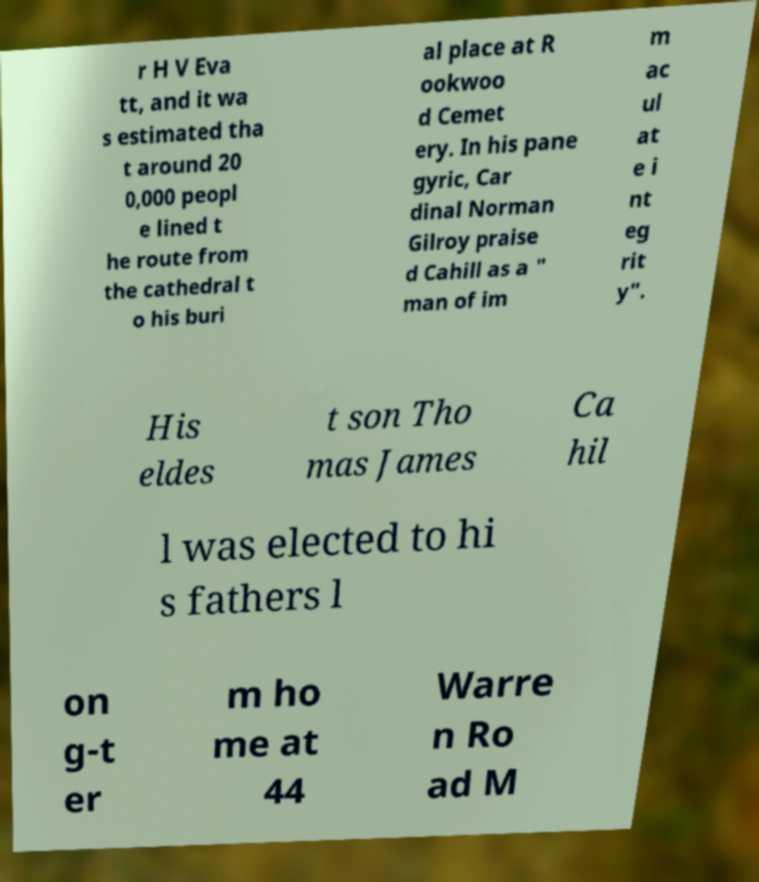I need the written content from this picture converted into text. Can you do that? r H V Eva tt, and it wa s estimated tha t around 20 0,000 peopl e lined t he route from the cathedral t o his buri al place at R ookwoo d Cemet ery. In his pane gyric, Car dinal Norman Gilroy praise d Cahill as a " man of im m ac ul at e i nt eg rit y". His eldes t son Tho mas James Ca hil l was elected to hi s fathers l on g-t er m ho me at 44 Warre n Ro ad M 